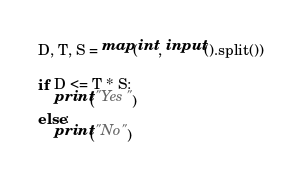<code> <loc_0><loc_0><loc_500><loc_500><_Python_>D, T, S = map(int, input().split())

if D <= T * S:
    print("Yes")
else:
    print("No")
</code> 